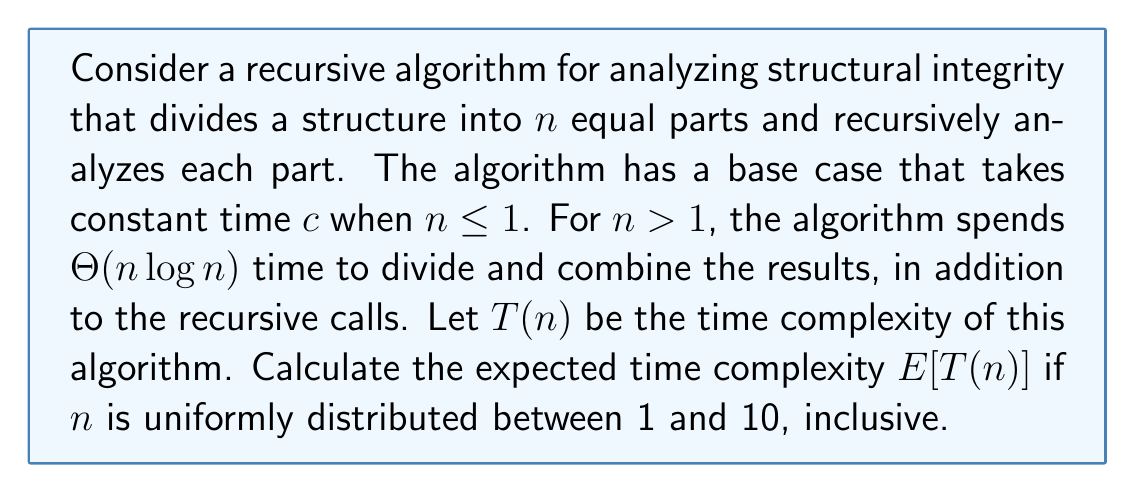What is the answer to this math problem? To solve this problem, we'll follow these steps:

1) First, let's write out the recurrence relation for $T(n)$:
   $$T(n) = \begin{cases}
   c & \text{if } n \leq 1 \\
   n T(n/n) + \Theta(n \log n) & \text{if } n > 1
   \end{cases}$$

2) Simplify the recurrence for $n > 1$:
   $$T(n) = n T(1) + \Theta(n \log n) = nc + \Theta(n \log n)$$

3) The probability of each $n$ from 1 to 10 is $\frac{1}{10}$ (uniform distribution).

4) Calculate $E[T(n)]$:
   $$E[T(n)] = \sum_{n=1}^{10} \frac{1}{10} T(n)$$

5) Expand the sum:
   $$E[T(n)] = \frac{1}{10}[c + \sum_{n=2}^{10} (nc + \Theta(n \log n))]$$

6) Simplify:
   $$E[T(n)] = \frac{1}{10}[c + c\sum_{n=2}^{10} n + \sum_{n=2}^{10} \Theta(n \log n)]$$

7) Calculate the sums:
   $$\sum_{n=2}^{10} n = \frac{10(10+1)}{2} - 1 = 54$$
   $$\sum_{n=2}^{10} n \log n \approx 185.13$$

8) Substitute back:
   $$E[T(n)] = \frac{1}{10}[c + 54c + \Theta(185.13)]$$
   $$E[T(n)] = 5.5c + \Theta(18.513)$$

9) Simplify to big-Theta notation:
   $$E[T(n)] = \Theta(c) + \Theta(\log n)$$
Answer: $\Theta(c + \log n)$ 